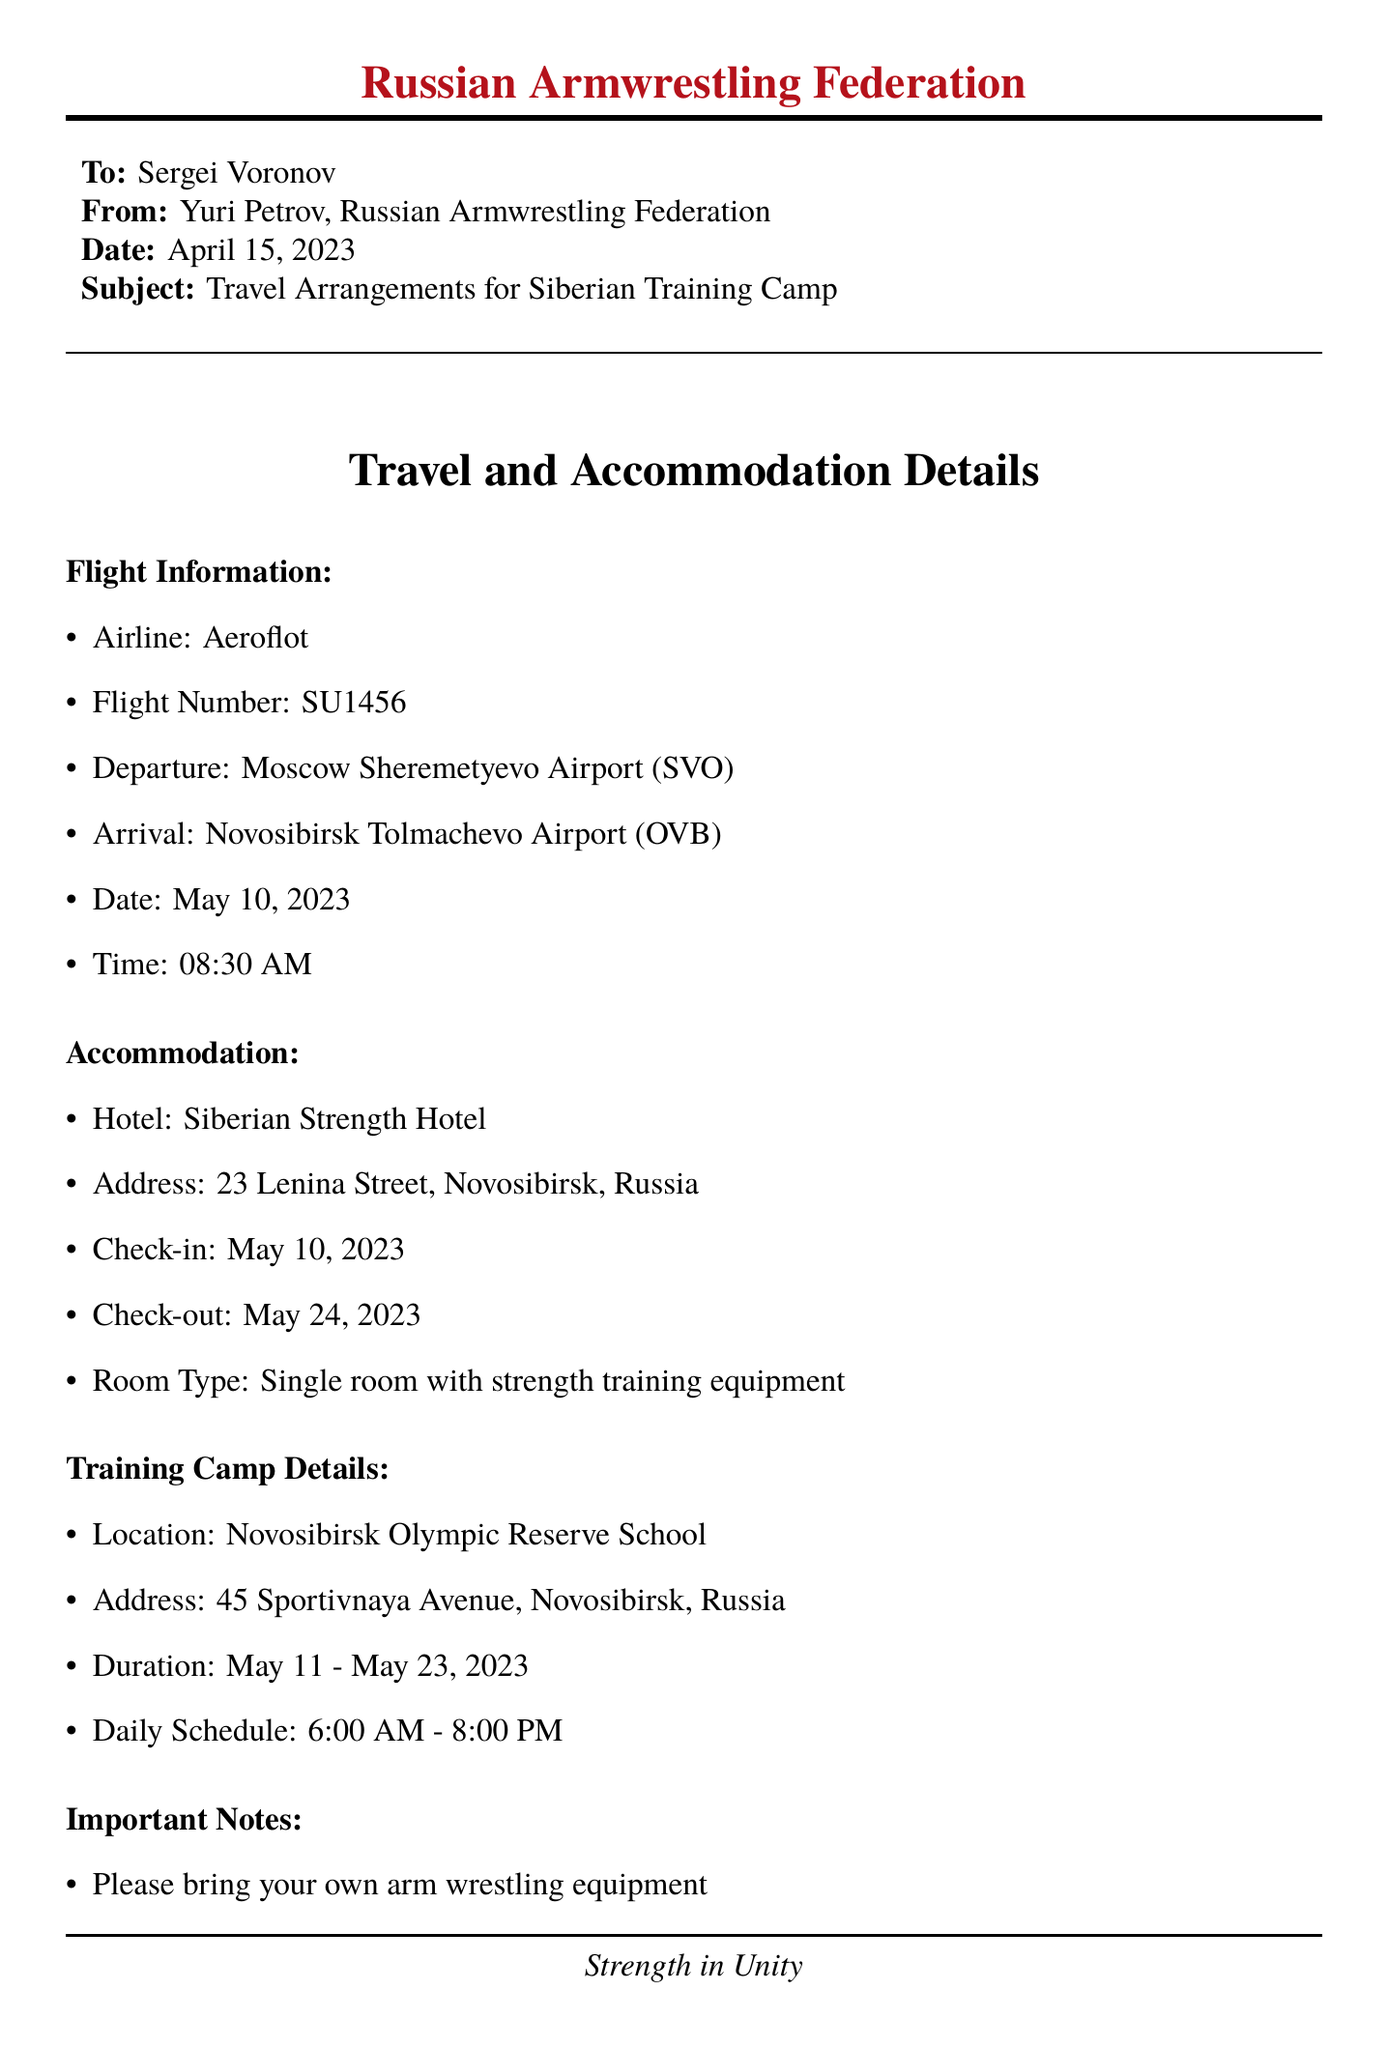What is the airline for the flight? The airline is listed in the flight information section of the document.
Answer: Aeroflot What is the flight number? The flight number is mentioned alongside the airline details in the document.
Answer: SU1456 On what date is the check-in at the hotel? The check-in date is specified in the accommodation section of the document.
Answer: May 10, 2023 Where is the training camp located? The location of the training camp is clearly stated in the training camp details section.
Answer: Novosibirsk Olympic Reserve School What is the duration of the training camp? The duration is indicated under the training camp details in the document.
Answer: May 11 - May 23, 2023 Who should be contacted for questions? The contact person is mentioned in the important notes section.
Answer: Coach Ivan Volkov What type of room will be provided at the hotel? The room type is specified in the accommodation section of the document.
Answer: Single room with strength training equipment What is the departure airport for the flight? The departure airport is found in the flight information section of the document.
Answer: Moscow Sheremetyevo Airport (SVO) By what date should the attendance be confirmed? The confirmation request provides this specific detail in the document.
Answer: April 25, 2023 